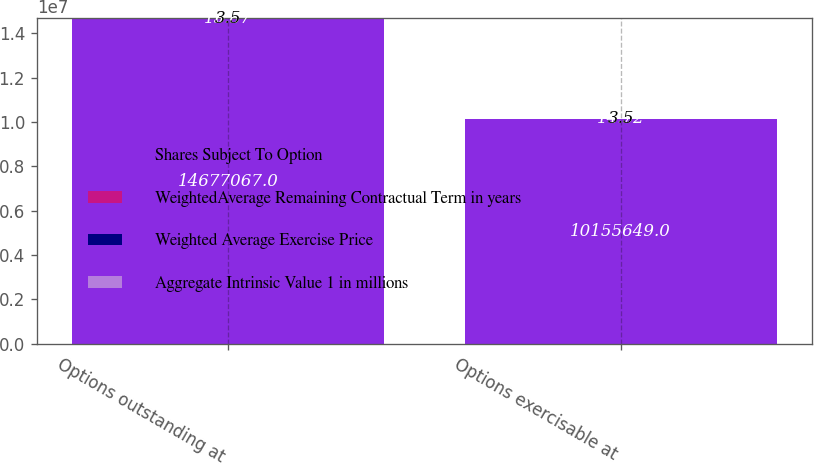<chart> <loc_0><loc_0><loc_500><loc_500><stacked_bar_chart><ecel><fcel>Options outstanding at<fcel>Options exercisable at<nl><fcel>Shares Subject To Option<fcel>1.46771e+07<fcel>1.01556e+07<nl><fcel>WeightedAverage Remaining Contractual Term in years<fcel>15.87<fcel>14.72<nl><fcel>Weighted Average Exercise Price<fcel>6.3<fcel>5.3<nl><fcel>Aggregate Intrinsic Value 1 in millions<fcel>3.5<fcel>3.5<nl></chart> 